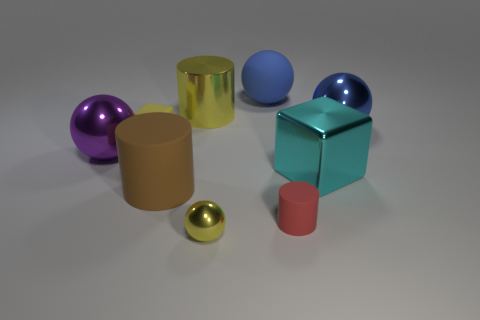Does the metallic cylinder have the same color as the tiny rubber cube?
Ensure brevity in your answer.  Yes. How many big shiny objects have the same color as the small ball?
Offer a very short reply. 1. What is the size of the red thing that is the same shape as the large brown object?
Ensure brevity in your answer.  Small. What color is the large sphere that is both on the left side of the tiny matte cylinder and to the right of the big brown thing?
Offer a very short reply. Blue. Is the purple ball made of the same material as the sphere that is right of the big rubber sphere?
Ensure brevity in your answer.  Yes. Is the number of yellow cylinders right of the small matte cylinder less than the number of purple shiny cylinders?
Offer a terse response. No. What number of other things are there of the same shape as the large blue rubber object?
Ensure brevity in your answer.  3. Is there any other thing that is the same color as the big rubber cylinder?
Provide a short and direct response. No. Does the big rubber sphere have the same color as the metal sphere right of the tiny yellow ball?
Provide a short and direct response. Yes. How many other objects are the same size as the yellow matte cube?
Offer a terse response. 2. 